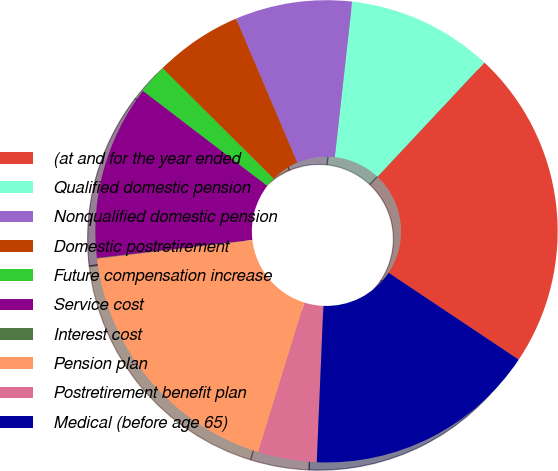Convert chart. <chart><loc_0><loc_0><loc_500><loc_500><pie_chart><fcel>(at and for the year ended<fcel>Qualified domestic pension<fcel>Nonqualified domestic pension<fcel>Domestic postretirement<fcel>Future compensation increase<fcel>Service cost<fcel>Interest cost<fcel>Pension plan<fcel>Postretirement benefit plan<fcel>Medical (before age 65)<nl><fcel>22.4%<fcel>10.2%<fcel>8.17%<fcel>6.14%<fcel>2.07%<fcel>12.24%<fcel>0.04%<fcel>18.34%<fcel>4.1%<fcel>16.3%<nl></chart> 